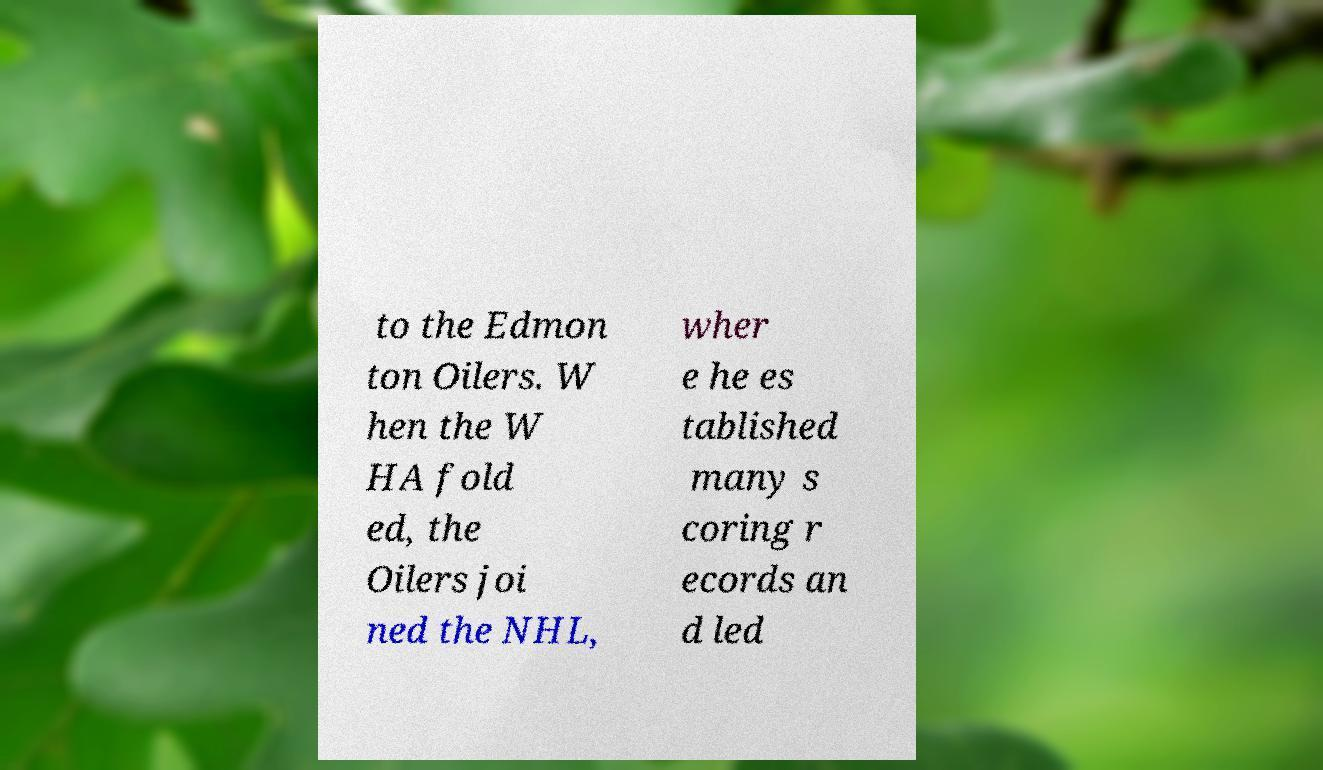Can you accurately transcribe the text from the provided image for me? to the Edmon ton Oilers. W hen the W HA fold ed, the Oilers joi ned the NHL, wher e he es tablished many s coring r ecords an d led 